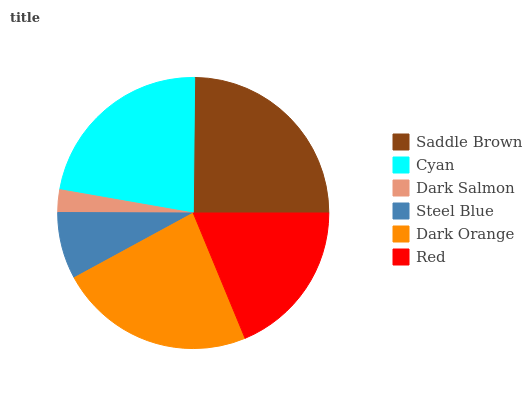Is Dark Salmon the minimum?
Answer yes or no. Yes. Is Saddle Brown the maximum?
Answer yes or no. Yes. Is Cyan the minimum?
Answer yes or no. No. Is Cyan the maximum?
Answer yes or no. No. Is Saddle Brown greater than Cyan?
Answer yes or no. Yes. Is Cyan less than Saddle Brown?
Answer yes or no. Yes. Is Cyan greater than Saddle Brown?
Answer yes or no. No. Is Saddle Brown less than Cyan?
Answer yes or no. No. Is Cyan the high median?
Answer yes or no. Yes. Is Red the low median?
Answer yes or no. Yes. Is Dark Orange the high median?
Answer yes or no. No. Is Dark Orange the low median?
Answer yes or no. No. 